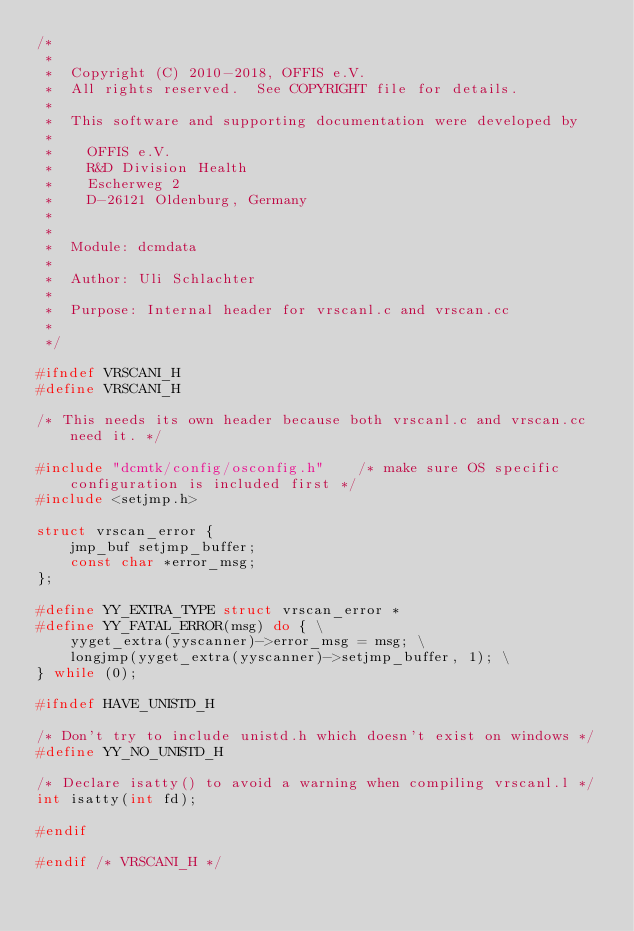<code> <loc_0><loc_0><loc_500><loc_500><_C_>/*
 *
 *  Copyright (C) 2010-2018, OFFIS e.V.
 *  All rights reserved.  See COPYRIGHT file for details.
 *
 *  This software and supporting documentation were developed by
 *
 *    OFFIS e.V.
 *    R&D Division Health
 *    Escherweg 2
 *    D-26121 Oldenburg, Germany
 *
 *
 *  Module: dcmdata
 *
 *  Author: Uli Schlachter
 *
 *  Purpose: Internal header for vrscanl.c and vrscan.cc
 *
 */

#ifndef VRSCANI_H
#define VRSCANI_H

/* This needs its own header because both vrscanl.c and vrscan.cc need it. */

#include "dcmtk/config/osconfig.h"    /* make sure OS specific configuration is included first */
#include <setjmp.h>

struct vrscan_error {
    jmp_buf setjmp_buffer;
    const char *error_msg;
};

#define YY_EXTRA_TYPE struct vrscan_error *
#define YY_FATAL_ERROR(msg) do { \
    yyget_extra(yyscanner)->error_msg = msg; \
    longjmp(yyget_extra(yyscanner)->setjmp_buffer, 1); \
} while (0);

#ifndef HAVE_UNISTD_H

/* Don't try to include unistd.h which doesn't exist on windows */
#define YY_NO_UNISTD_H

/* Declare isatty() to avoid a warning when compiling vrscanl.l */
int isatty(int fd);

#endif

#endif /* VRSCANI_H */
</code> 